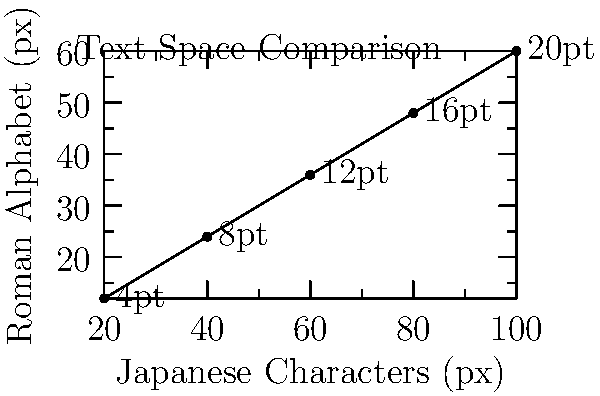Based on the comparison chart of text space requirements for Japanese characters vs. Roman alphabet in app design, what is the approximate ratio of space needed for Japanese characters compared to Roman alphabet characters at various font sizes? To determine the ratio of space needed for Japanese characters compared to Roman alphabet characters, we'll follow these steps:

1. Analyze the data points on the graph for different font sizes:
   - 20pt: Japanese (100px) vs Roman (60px)
   - 16pt: Japanese (80px) vs Roman (48px)
   - 12pt: Japanese (60px) vs Roman (36px)
   - 8pt: Japanese (40px) vs Roman (24px)
   - 4pt: Japanese (20px) vs Roman (12px)

2. Calculate the ratio for each font size:
   - 20pt: 100 / 60 = 1.67
   - 16pt: 80 / 48 = 1.67
   - 12pt: 60 / 36 = 1.67
   - 8pt: 40 / 24 = 1.67
   - 4pt: 20 / 12 = 1.67

3. Observe that the ratio remains constant across all font sizes.

4. Express the ratio as a simplified fraction:
   1.67 ≈ 5/3

Therefore, the approximate ratio of space needed for Japanese characters compared to Roman alphabet characters is 5:3 or 1.67:1 across all font sizes.
Answer: 5:3 